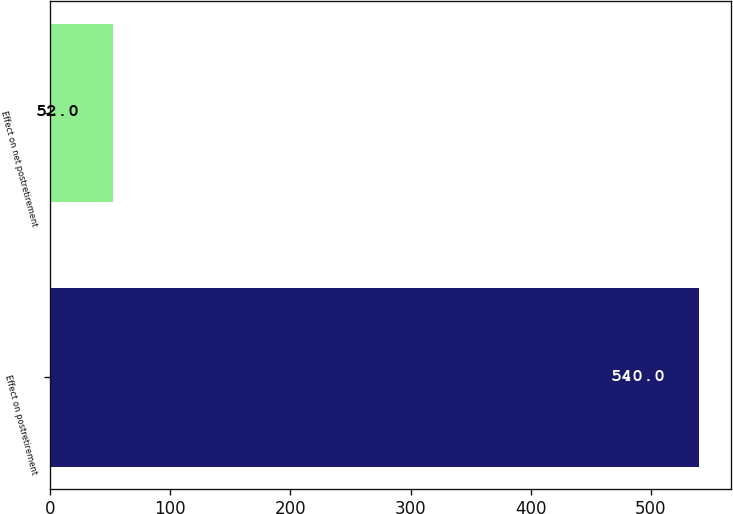Convert chart. <chart><loc_0><loc_0><loc_500><loc_500><bar_chart><fcel>Effect on postretirement<fcel>Effect on net postretirement<nl><fcel>540<fcel>52<nl></chart> 